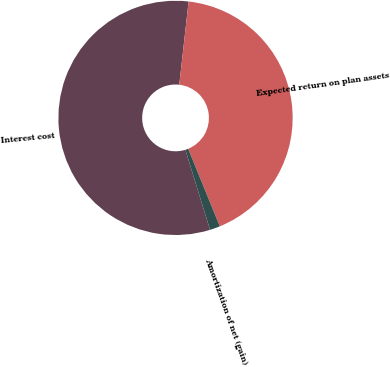Convert chart to OTSL. <chart><loc_0><loc_0><loc_500><loc_500><pie_chart><fcel>Interest cost<fcel>Expected return on plan assets<fcel>Amortization of net (gain)<nl><fcel>56.54%<fcel>42.05%<fcel>1.41%<nl></chart> 